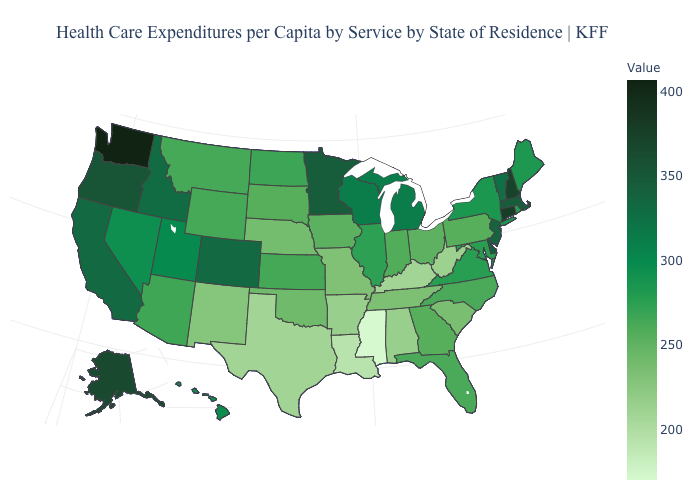Among the states that border Tennessee , does Virginia have the highest value?
Write a very short answer. Yes. Which states hav the highest value in the West?
Write a very short answer. Washington. Among the states that border Illinois , which have the lowest value?
Quick response, please. Kentucky. 